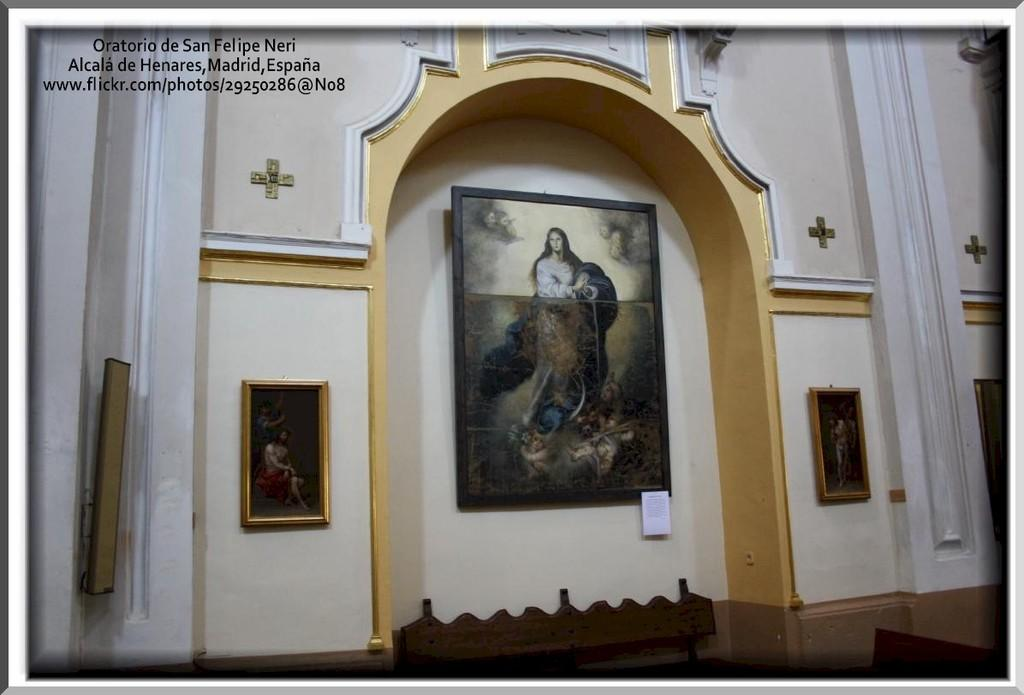What can be seen on the wall in the image? There are frames on the wall in the image. Is there any text or symbol in the image? Yes, there is a watermark in the top left side of the image. What type of texture can be seen on the frames in the image? There is no information about the texture of the frames in the image, as the provided facts only mention their presence on the wall. 